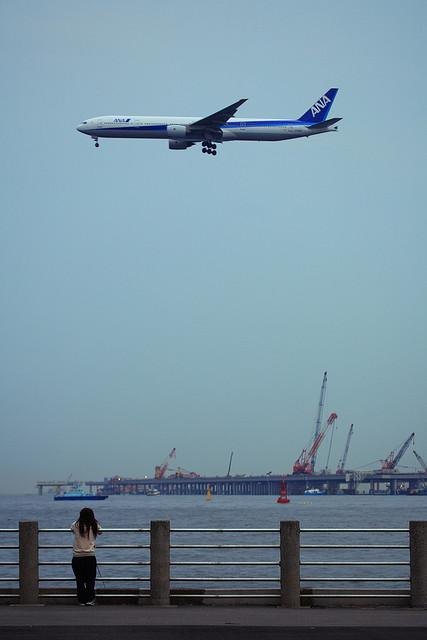From what country does ANA hail from? japan 